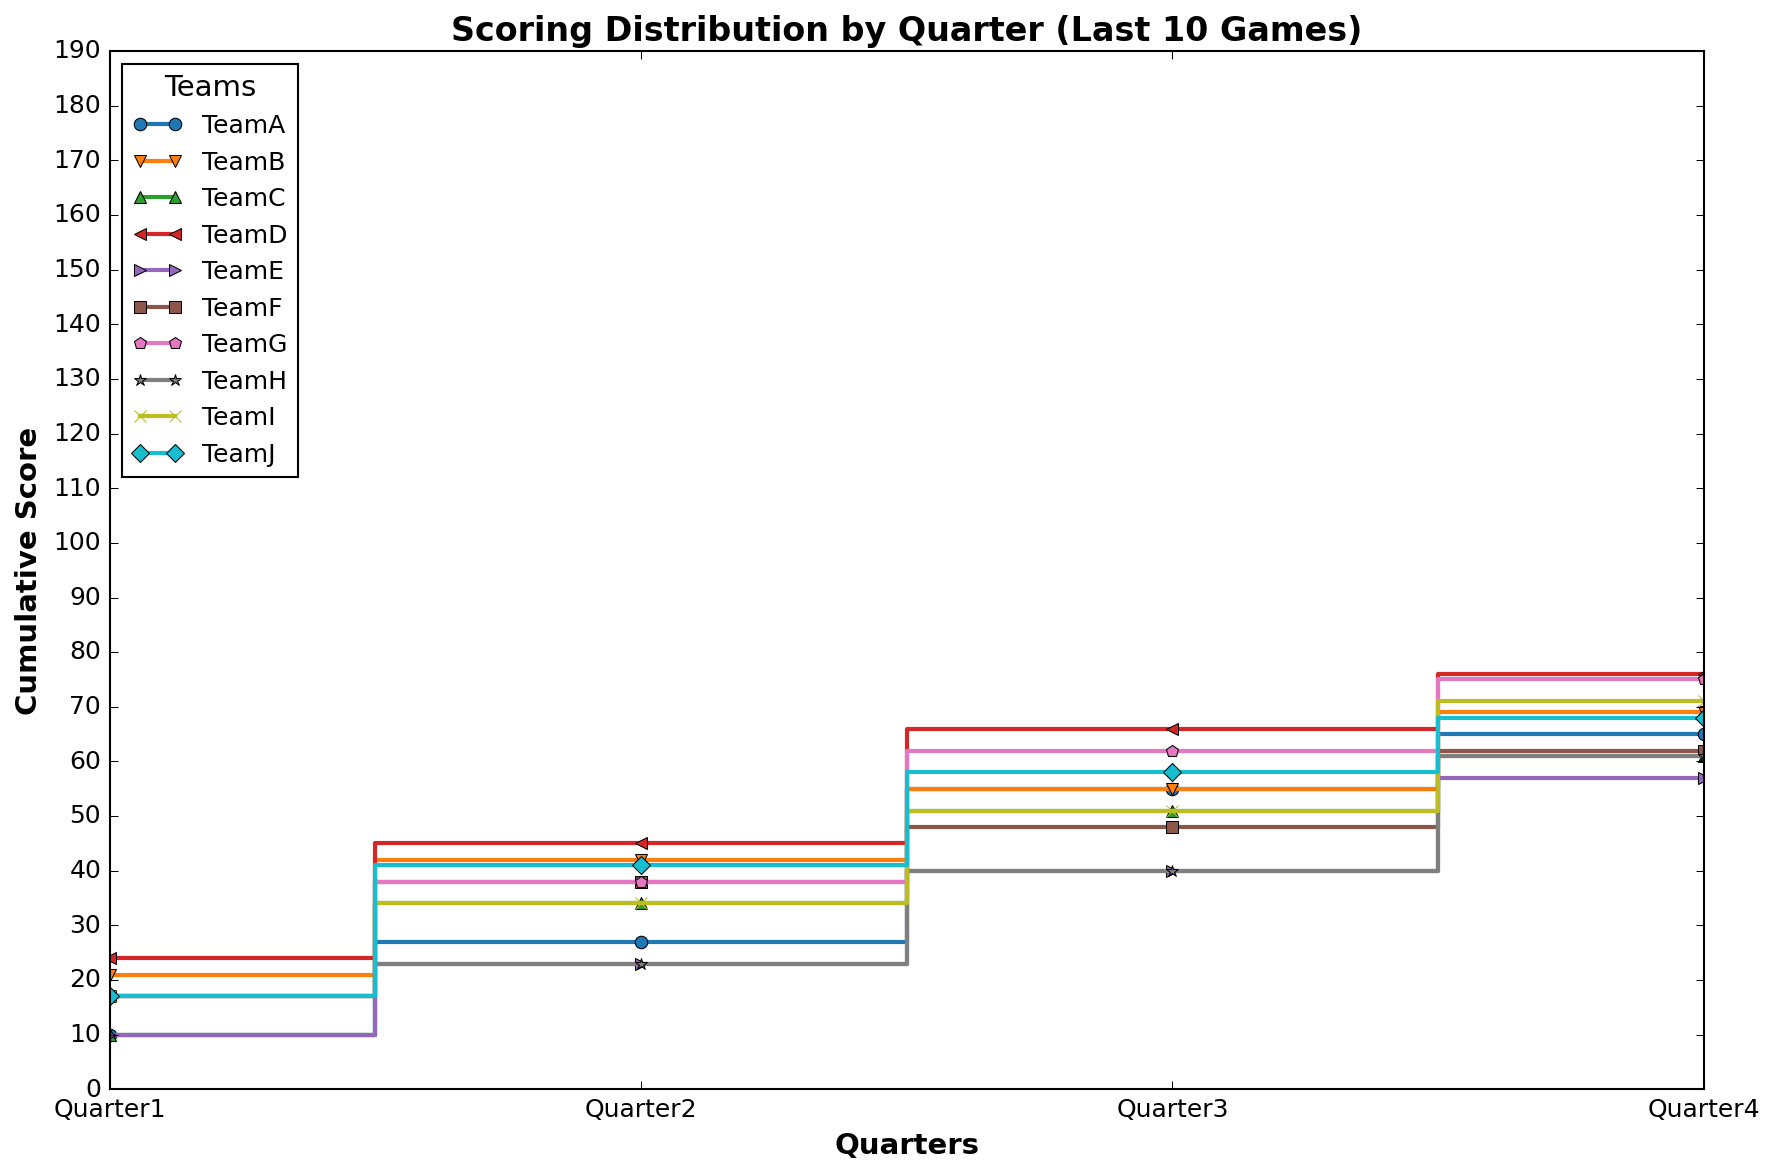What team has the highest cumulative score by the end of the fourth quarter? Look at the stairs plot and identify the team with the highest point at the end of the fourth quarter. Compare the cumulative scores of all teams at the fourth quarter.
Answer: TeamI Which team shows the most consistent scoring across all four quarters? Observe the stairs plot and identify a team whose cumulative score line has the most even distribution of increases across all four quarters. This means the team has similar scoring in each quarter.
Answer: TeamI Which quarter had the highest increase in cumulative score for TeamG? Follow the line representing TeamG and identify the quarter where the step, or increase, in the cumulative score is the largest.
Answer: Quarter3 What's the average cumulative score at the end of Quarter 2 for all teams? Sum the cumulative scores for all teams at the end of Quarter 2 and then divide by the number of teams. Total score at Quarter 2 = 71, number of teams = 10, so average = 71 / 10.
Answer: 7.1 How does TeamA's cumulative score at the end of Quarter 3 compare to TeamB's? Identify the cumulative scores for TeamA and TeamB at the end of Quarter 3 by following their respective lines on the plot. Then compare these scores.
Answer: TeamA's cumulative score is higher Which team shows a sudden large increase in cumulative score in any particular quarter? Look at the plot to identify a team that has a noticeably steep step in any one of the quarters. This team shows a sudden large increase.
Answer: TeamJ in Quarter2 How many teams have a cumulative score of 30 or more by the end of the fourth quarter? Count the number of teams whose cumulative scores are 30 or more at the end of the fourth quarter by examining the positions of the end points on the plot.
Answer: 6 Compare the cumulative scores of TeamE and TeamF at the end of the first and second quarters. Which team scores higher at these points? Identify and compare the cumulative scores of TeamE and TeamF at the end of the first and second quarters by following their respective lines on the plot at these points.
Answer: TeamE scores higher What is the overall trend in scores for TeamD across the quarters? Observe the stairs plot line for TeamD and describe the general pattern of their cumulative score changes from Quarter 1 to Quarter 4.
Answer: Decreases What's the total score for TeamC by the end of the third quarter? Follow TeamC's line up to the end of Quarter 3 and identify the cumulative score at that point.
Answer: 20 